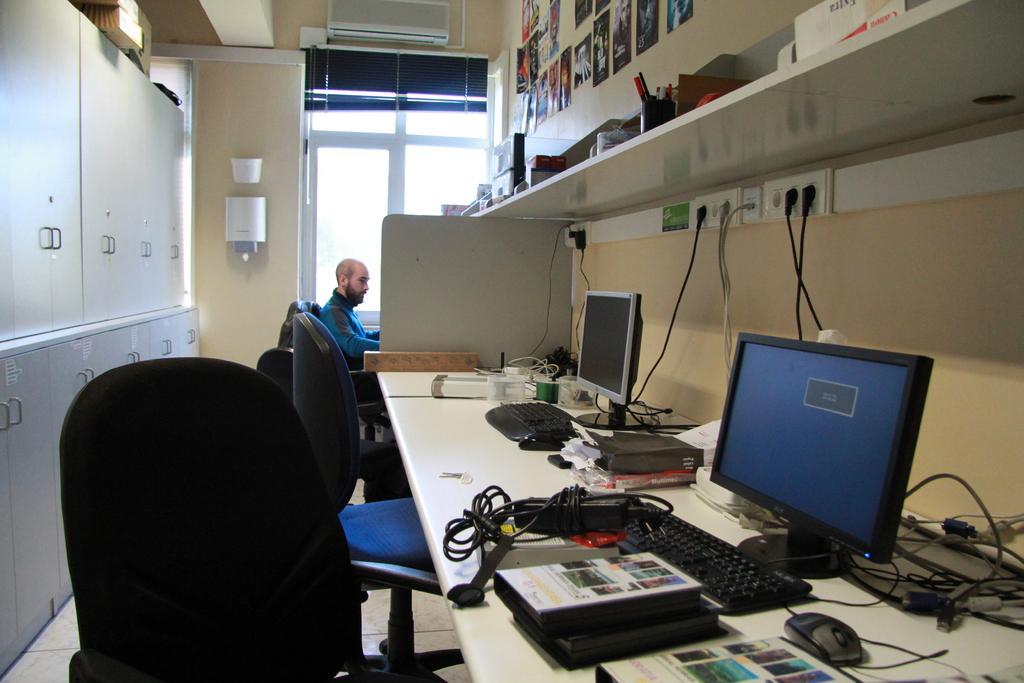Describe this image in one or two sentences. In this image I see the desktop and there are monitors, keyboards, mouses and many things on it. I also see there are few cupboards, chairs, few photos on the wall, window and a man over here. 